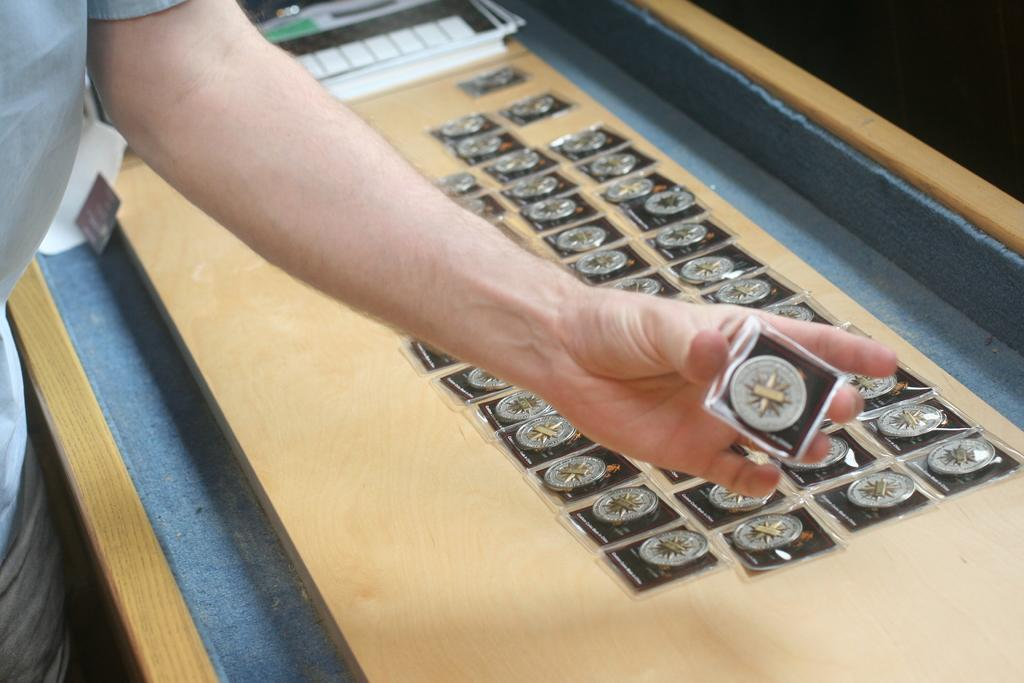Who or what is the main subject in the image? There is a person in the image. What is the person holding in their hand? The person is holding something in their hand, but we cannot determine what it is from the given facts. What can be seen in the background of the image? There is a wooden table in the background of the image. What is on the wooden table? There are items on the wooden table, but we cannot determine what they are from the given facts. What type of class is being taught in the image? There is no indication of a class or any teaching activity in the image. What channel is the person watching on the wooden table? There is no television or any reference to a channel in the image. 